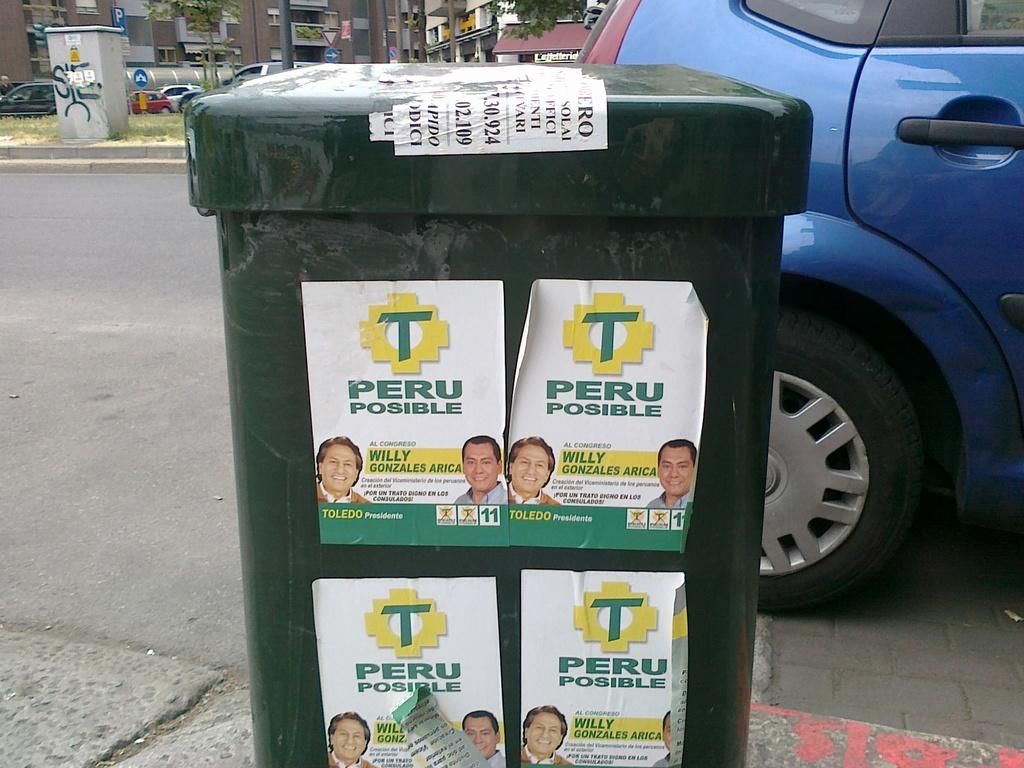<image>
Present a compact description of the photo's key features. Posters with the letter T on them are plastered next to one another. 